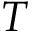Convert formula to latex. <formula><loc_0><loc_0><loc_500><loc_500>T</formula> 